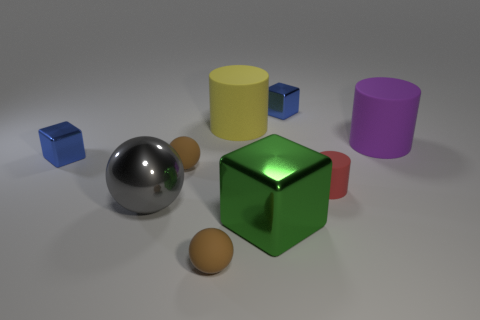Subtract all large cubes. How many cubes are left? 2 Subtract all green cubes. How many cubes are left? 2 Subtract all cylinders. How many objects are left? 6 Subtract all red spheres. Subtract all brown cylinders. How many spheres are left? 3 Subtract all gray blocks. How many brown spheres are left? 2 Subtract all small cylinders. Subtract all small things. How many objects are left? 3 Add 8 big green shiny objects. How many big green shiny objects are left? 9 Add 9 blue metallic balls. How many blue metallic balls exist? 9 Subtract 2 brown balls. How many objects are left? 7 Subtract 1 spheres. How many spheres are left? 2 